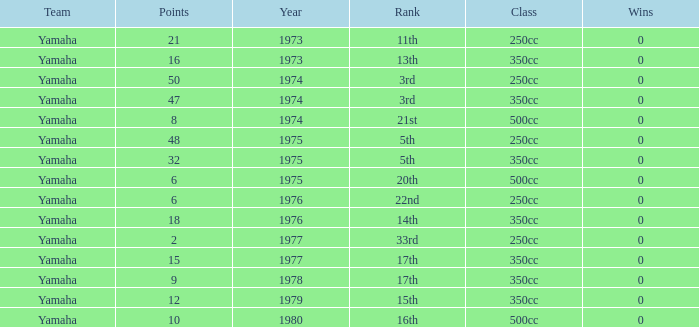Which Points is the lowest one that has a Year larger than 1974, and a Rank of 15th? 12.0. 